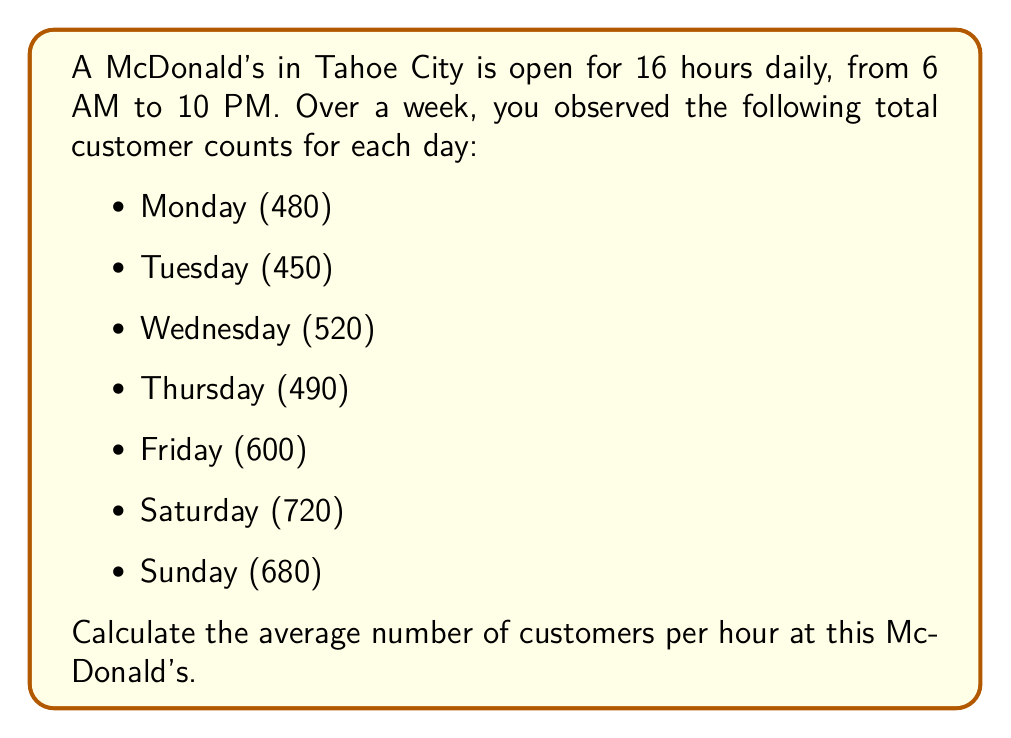Give your solution to this math problem. Let's approach this step-by-step:

1. Calculate the total number of customers for the week:
   $$ \text{Total customers} = 480 + 450 + 520 + 490 + 600 + 720 + 680 = 3940 $$

2. Calculate the total number of hours the restaurant is open in a week:
   $$ \text{Hours per day} = 16 $$
   $$ \text{Days in a week} = 7 $$
   $$ \text{Total hours} = 16 \times 7 = 112 \text{ hours} $$

3. Calculate the average number of customers per hour:
   $$ \text{Average customers per hour} = \frac{\text{Total customers}}{\text{Total hours}} $$
   $$ = \frac{3940}{112} $$
   $$ \approx 35.18 \text{ customers per hour} $$

4. Round to the nearest whole number:
   $$ \text{Rounded average} = 35 \text{ customers per hour} $$
Answer: 35 customers per hour 